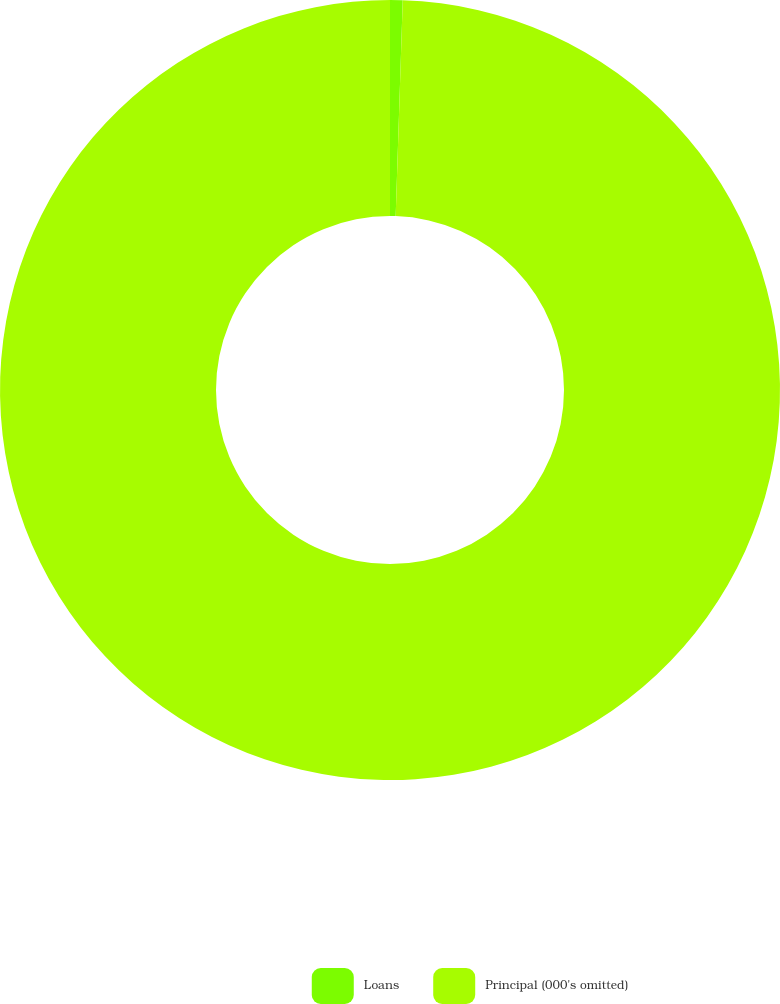Convert chart. <chart><loc_0><loc_0><loc_500><loc_500><pie_chart><fcel>Loans<fcel>Principal (000's omitted)<nl><fcel>0.52%<fcel>99.48%<nl></chart> 